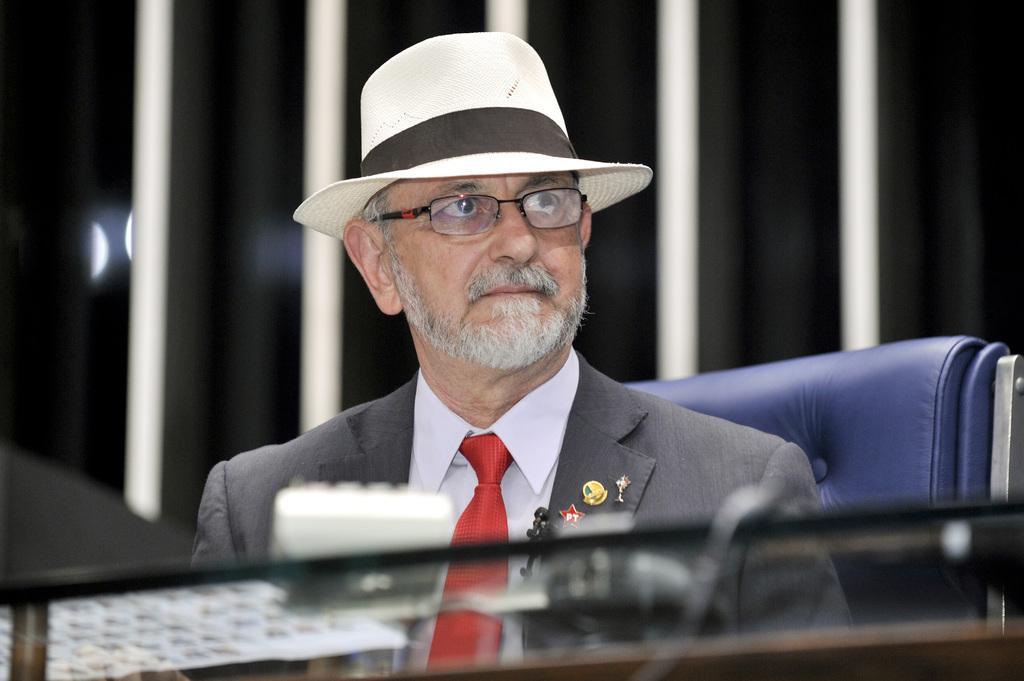Could you give a brief overview of what you see in this image? In this picture there is a man who is wearing hat, spectacle and suit. He is sitting on the chair. On the bottom we can see glass table on which there is a remote. On the back we can see dark. 